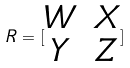<formula> <loc_0><loc_0><loc_500><loc_500>R = [ \begin{matrix} W & X \\ Y & Z \end{matrix} ]</formula> 